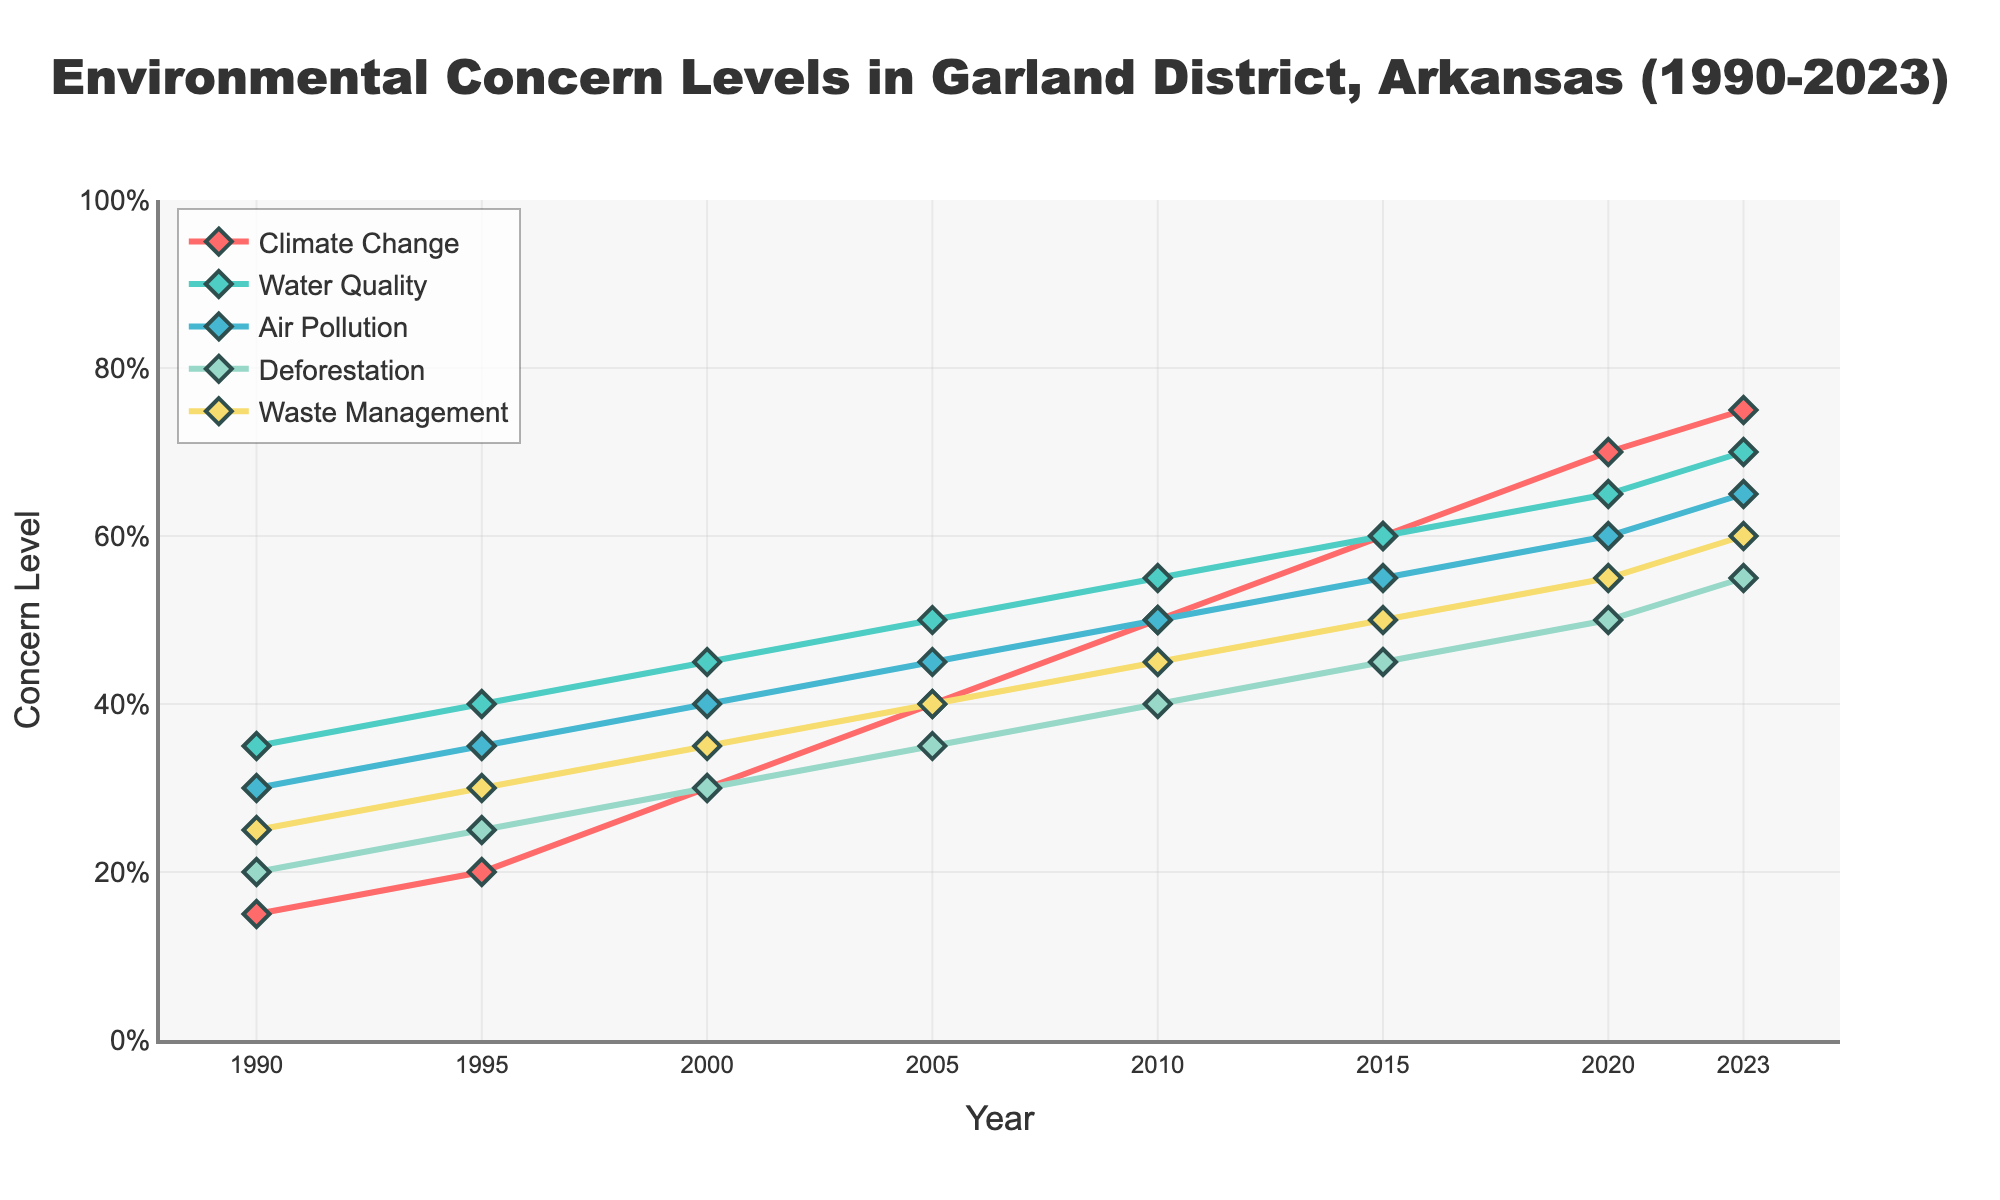What is the trend for environmental concern regarding climate change from 1990 to 2023? From the figure, we observe that the concern level for climate change increases steadily from 15% in 1990 to 75% in 2023.
Answer: Increasing trend How did the concern levels for air pollution and waste management compare in 2010? In 2010, the concern level for air pollution was 50%, while for waste management it was 45%.
Answer: 50% vs 45% Which environmental issue had the highest concern level in 2020? By looking at the figure for 2020, water quality has the highest concern level at 65%.
Answer: Water quality By how much did the concern for deforestation increase from 1990 to 2023? The concern level for deforestation increased from 20% in 1990 to 55% in 2023. The increase is 55% - 20% = 35%.
Answer: 35% In which year did the concern for waste management reach 50%? In the figure, the concern for waste management reached 50% in 2015.
Answer: 2015 Which environmental issue showed the most consistent increase in concern levels over the time period? All issues show consistent increases, but climate change shows a steady increase from 15% in 1990 to 75% in 2023, without any plateauing.
Answer: Climate change How does the concern for water quality in 2000 compare to the concern for climate change in 2023? The concern level for water quality in 2000 is 45%, while for climate change in 2023 it is 75%.
Answer: 45% vs 75% What is the average concern level for deforestation from 1990 to 2023? The concern levels for deforestation are [20, 25, 30, 35, 40, 45, 50, 55]. Summing these: 20 + 25 + 30 + 35 + 40 + 45 + 50 + 55 = 300. There are 8 data points, so the average is 300 / 8 = 37.5%.
Answer: 37.5% Which issue experienced the greatest increase in concern percentage between 1990 and 2023? The increase for each issue is calculated by subtracting the 1990 value from the 2023 value. Climate Change: (75-15)=60, Water Quality: (70-35)=35, Air Pollution: (65-30)=35, Deforestation: (55-20)=35, Waste Management: (60-25)=35. Climate change experienced the greatest increase of 60%.
Answer: Climate change Are there any environmental issues that had equal concern levels in any year? By examining the figure, in 2015, both climate change and water quality had equal concern levels at 60%.
Answer: Yes, in 2015 